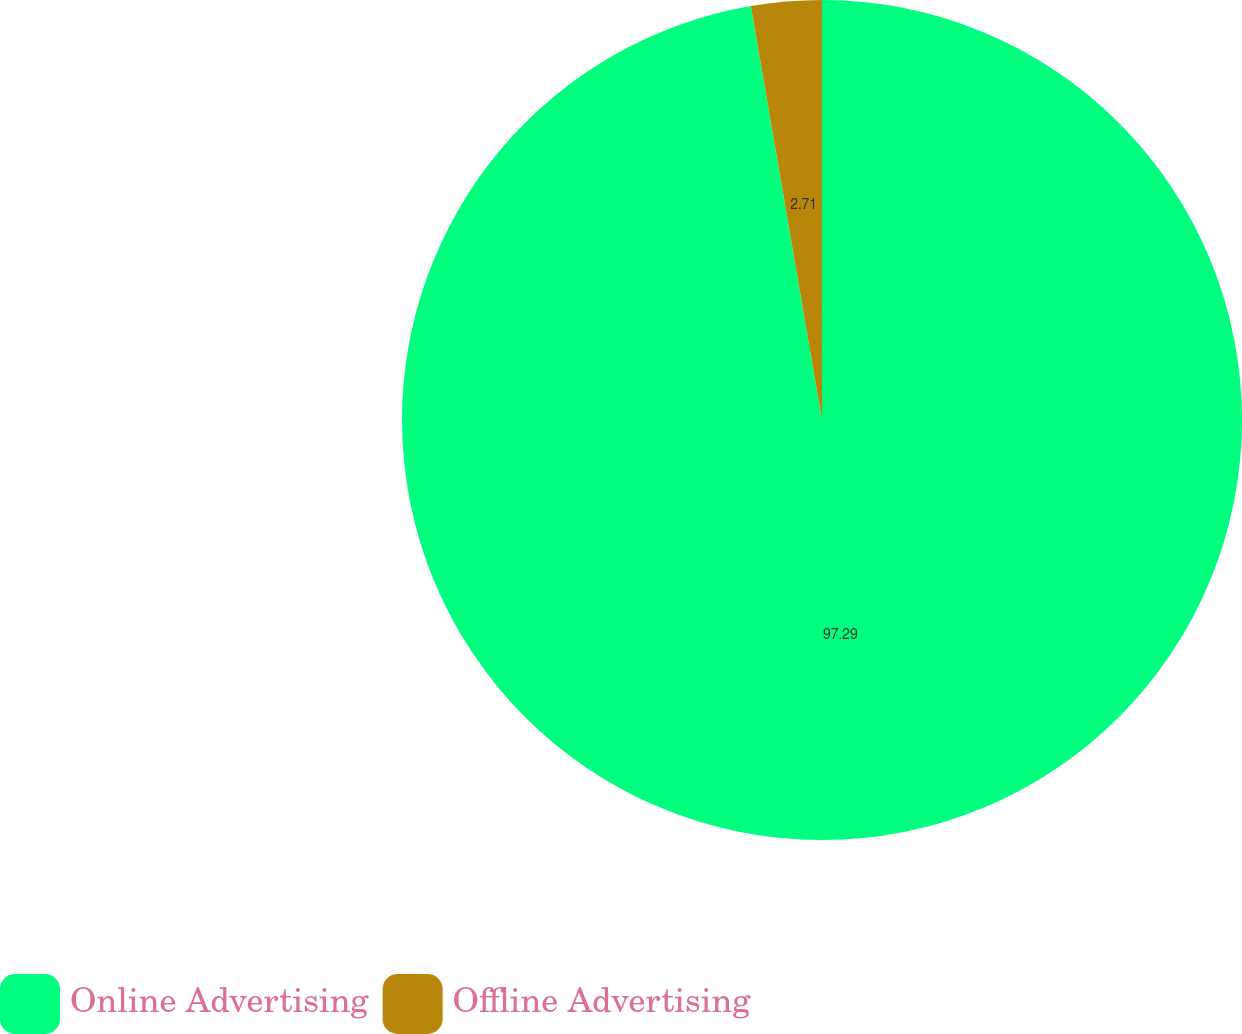Convert chart. <chart><loc_0><loc_0><loc_500><loc_500><pie_chart><fcel>Online Advertising<fcel>Offline Advertising<nl><fcel>97.29%<fcel>2.71%<nl></chart> 